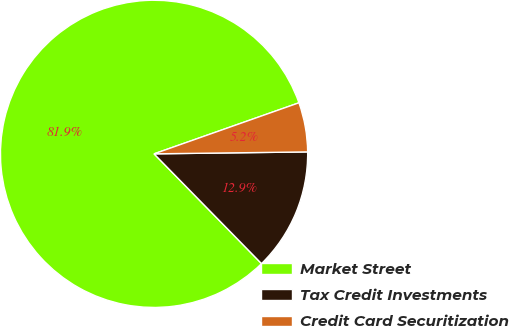<chart> <loc_0><loc_0><loc_500><loc_500><pie_chart><fcel>Market Street<fcel>Tax Credit Investments<fcel>Credit Card Securitization<nl><fcel>81.94%<fcel>12.87%<fcel>5.19%<nl></chart> 